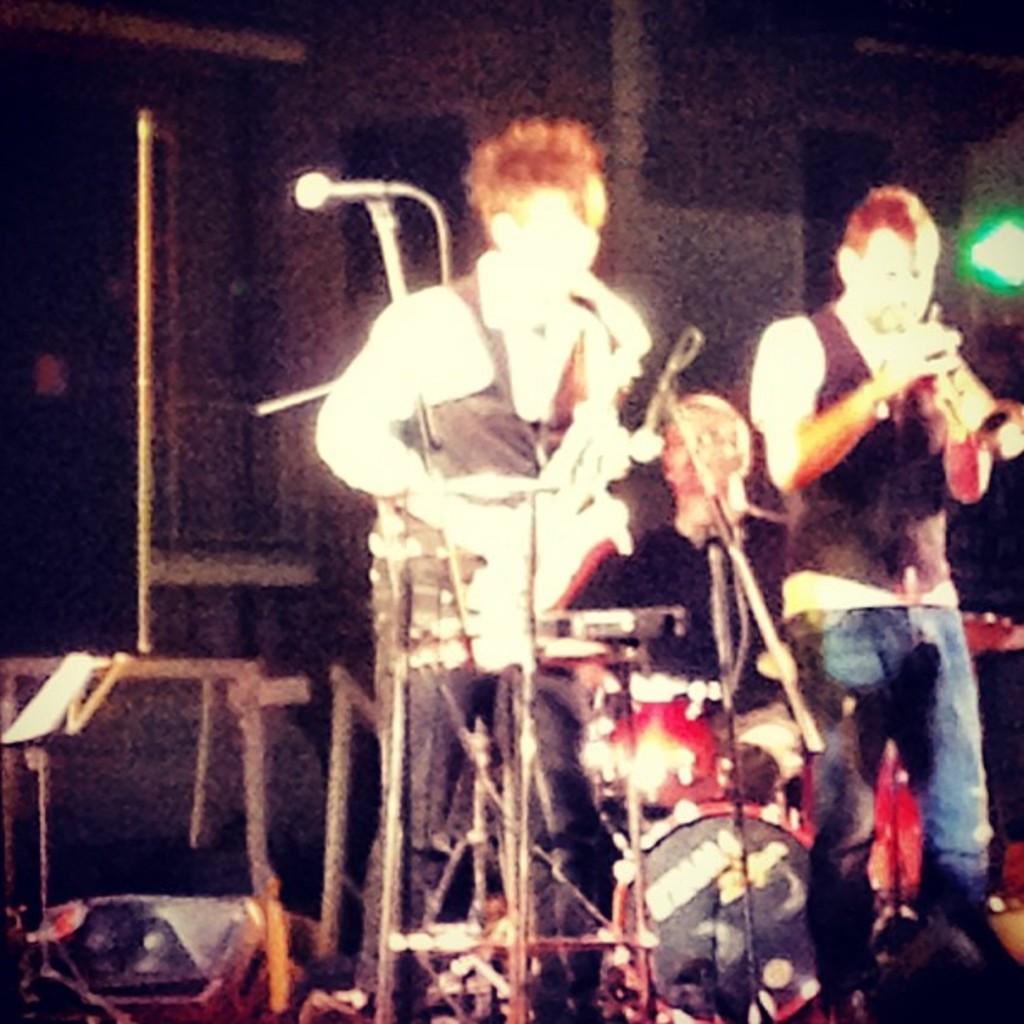Describe this image in one or two sentences. In this image I can see a two persons are standing and playing musical instrument. Background is black in color. I can see light,mics and a stands. 